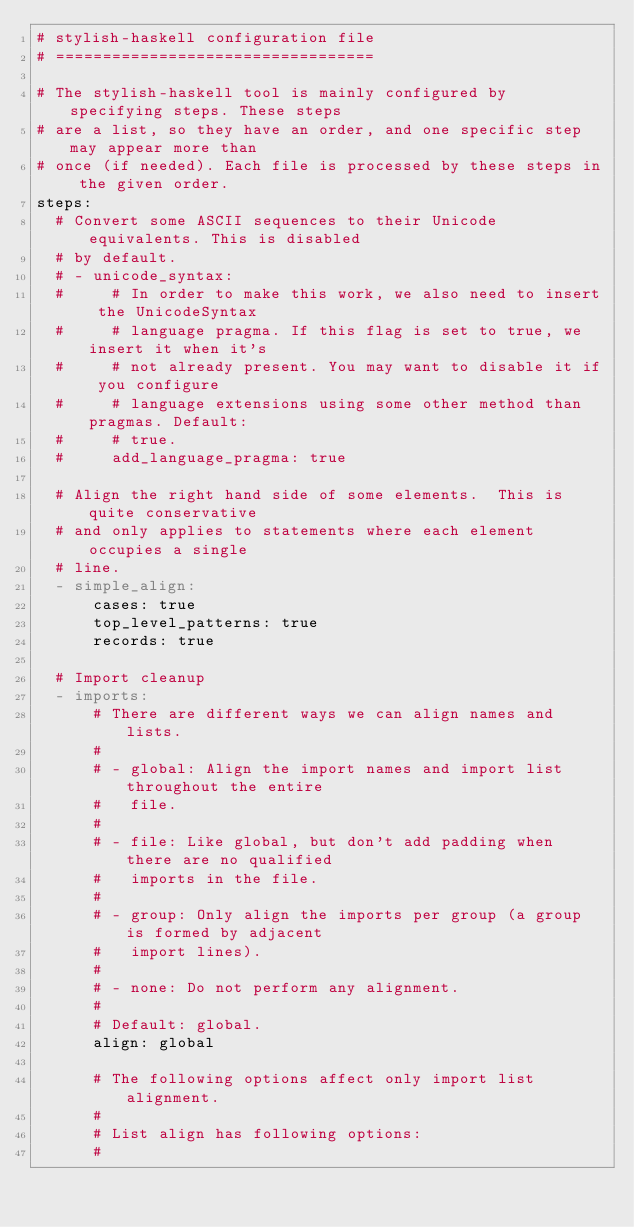<code> <loc_0><loc_0><loc_500><loc_500><_YAML_># stylish-haskell configuration file
# ==================================

# The stylish-haskell tool is mainly configured by specifying steps. These steps
# are a list, so they have an order, and one specific step may appear more than
# once (if needed). Each file is processed by these steps in the given order.
steps:
  # Convert some ASCII sequences to their Unicode equivalents. This is disabled
  # by default.
  # - unicode_syntax:
  #     # In order to make this work, we also need to insert the UnicodeSyntax
  #     # language pragma. If this flag is set to true, we insert it when it's
  #     # not already present. You may want to disable it if you configure
  #     # language extensions using some other method than pragmas. Default:
  #     # true.
  #     add_language_pragma: true

  # Align the right hand side of some elements.  This is quite conservative
  # and only applies to statements where each element occupies a single
  # line.
  - simple_align:
      cases: true
      top_level_patterns: true
      records: true

  # Import cleanup
  - imports:
      # There are different ways we can align names and lists.
      #
      # - global: Align the import names and import list throughout the entire
      #   file.
      #
      # - file: Like global, but don't add padding when there are no qualified
      #   imports in the file.
      #
      # - group: Only align the imports per group (a group is formed by adjacent
      #   import lines).
      #
      # - none: Do not perform any alignment.
      #
      # Default: global.
      align: global

      # The following options affect only import list alignment.
      #
      # List align has following options:
      #</code> 